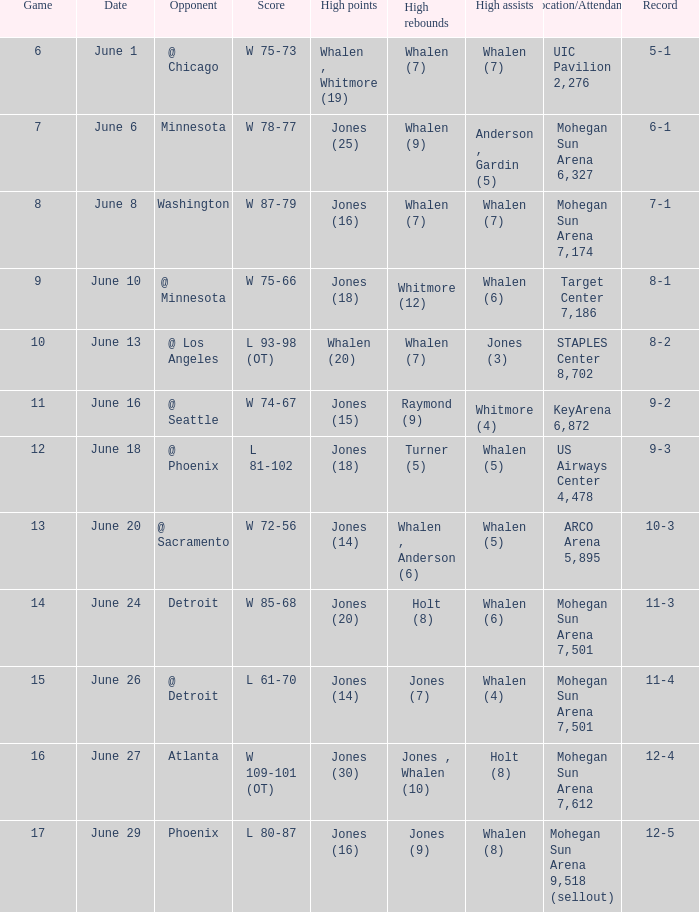What is the event on june 29? 17.0. 